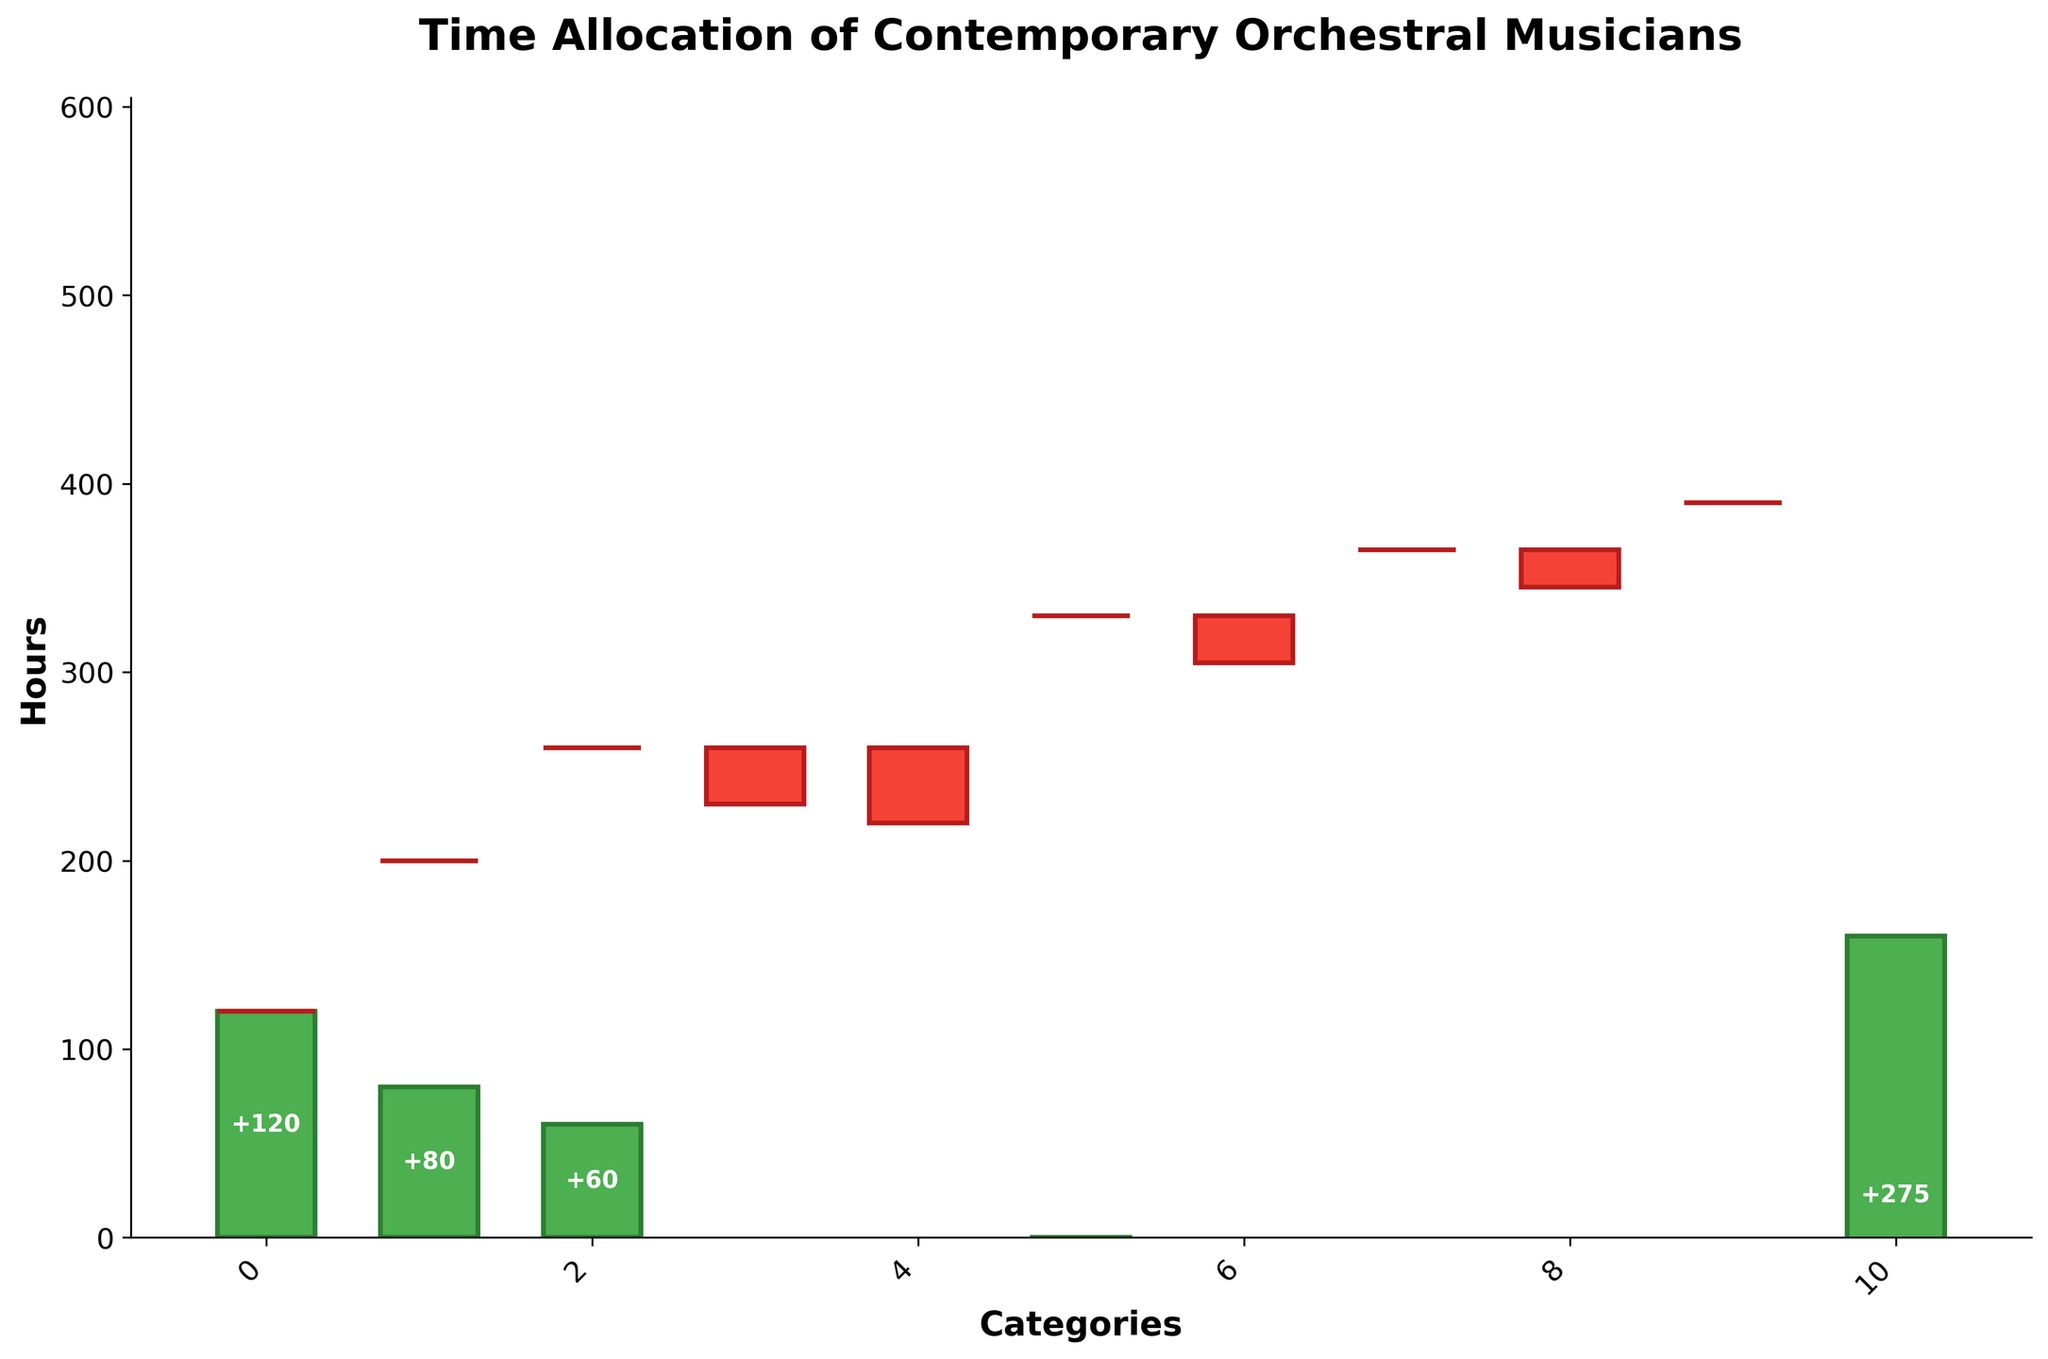What's the total number of hours allocated to traditional repertoire? The height of the "Traditional Repertoire" bar shows 120 hours.
Answer: 120 Which category has the highest allocation of hours after "Traditional Repertoire"? By comparing the heights of all the bars, aside from "Traditional Repertoire," the bar for "Orchestral Rehearsals" has the second-highest allocation with 70 hours.
Answer: Orchestral Rehearsals What is the difference in hours between Modern Compositions and Cross-Genre Collaborations? The "Modern Compositions" bar shows 80 hours, and the "Cross-Genre Collaborations" bar shows 60 hours. The difference is 80 - 60.
Answer: 20 What is the net positive allocation among the categories excluding the negative allocations? Summing the heights of the positive bars: 120 (Traditional Repertoire) + 80 (Modern Compositions) + 60 (Cross-Genre Collaborations) + 70 (Orchestral Rehearsals) + 35 (New Music Festivals) + 25 (Recording Sessions) = 390
Answer: 390 What is the impact of negative allocations on the total hours? Summing the heights of the negative bars: -30 (Chamber Music) + -40 (Solo Practice) + -25 (Music Education Outreach) + -20 (Community Performances) = -115
Answer: -115 What is the total change in hours from the start to the end of the waterfall chart? Start with 0, sum the Hours column, 120 + 80 + 60 - 30 - 40 + 70 - 25 + 35 - 20 + 25 = 275
Answer: 275 How does the time spent on recording sessions compare to that on music education outreach? The "Recording Sessions" bar shows 25 hours, whereas the "Music Education Outreach" bar shows -25 hours, indicating that recording sessions receive 50 hours more.
Answer: 50 Are there more categories with positive or negative hour allocations? There are six categories with positive allocations (Traditional Repertoire, Modern Compositions, Cross-Genre Collaborations, Orchestral Rehearsals, New Music Festivals, Recording Sessions) and four with negative allocations (Chamber Music, Solo Practice, Music Education Outreach, Community Performances).
Answer: Positive How much more time is allocated to Modern Compositions compared to Solo Practice? The "Modern Compositions" bar shows 80 hours and "Solo Practice" shows -40 hours. The difference is 80 - (-40).
Answer: 120 